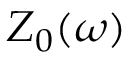<formula> <loc_0><loc_0><loc_500><loc_500>Z _ { 0 } ( \omega )</formula> 